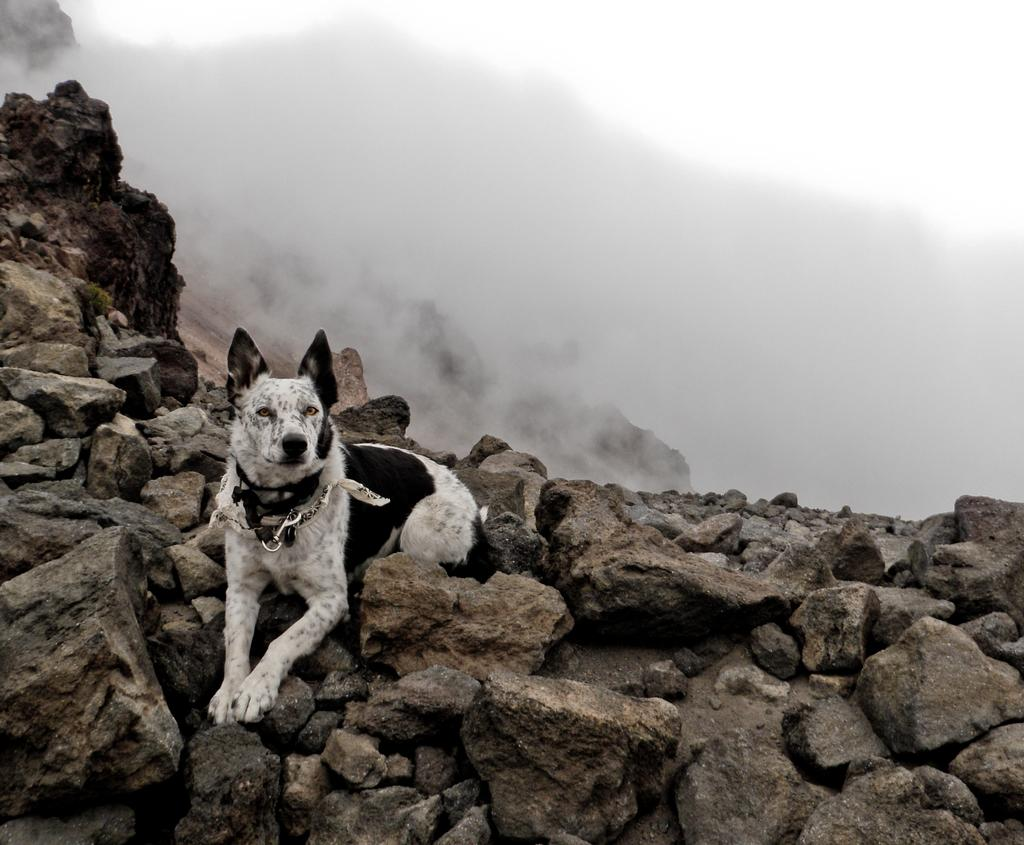What animal is present in the image? There is a dog in the image. Where is the dog located in the image? The dog is on the rocks. Which side of the image do the rocks appear on? The rocks are on the left side of the image. Are there rocks visible at the bottom of the image? Yes, there are rocks at the bottom side of the image. What can be seen at the top side of the image? There is smoke at the top side of the image. What religious symbol is present in the image? There is no religious symbol present in the image. What is the title of the image? The image does not have a title. How does the dog's health appear in the image? The image does not provide any information about the dog's health. 